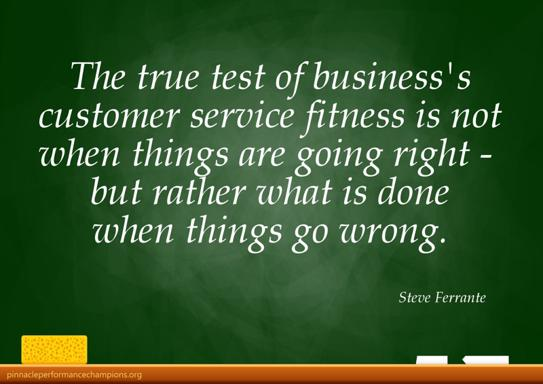Aside from 'resolve issues when things go wrong,' what other customer service qualities could be inferred from the quote's context? The quote also implies qualities like resilience, adaptability, and responsiveness. This context suggests that aside from resolving issues, effective customer service should proactively anticipate potential problems and address them with agility, ensuring minimal disruption and maintaining customer loyalty. 